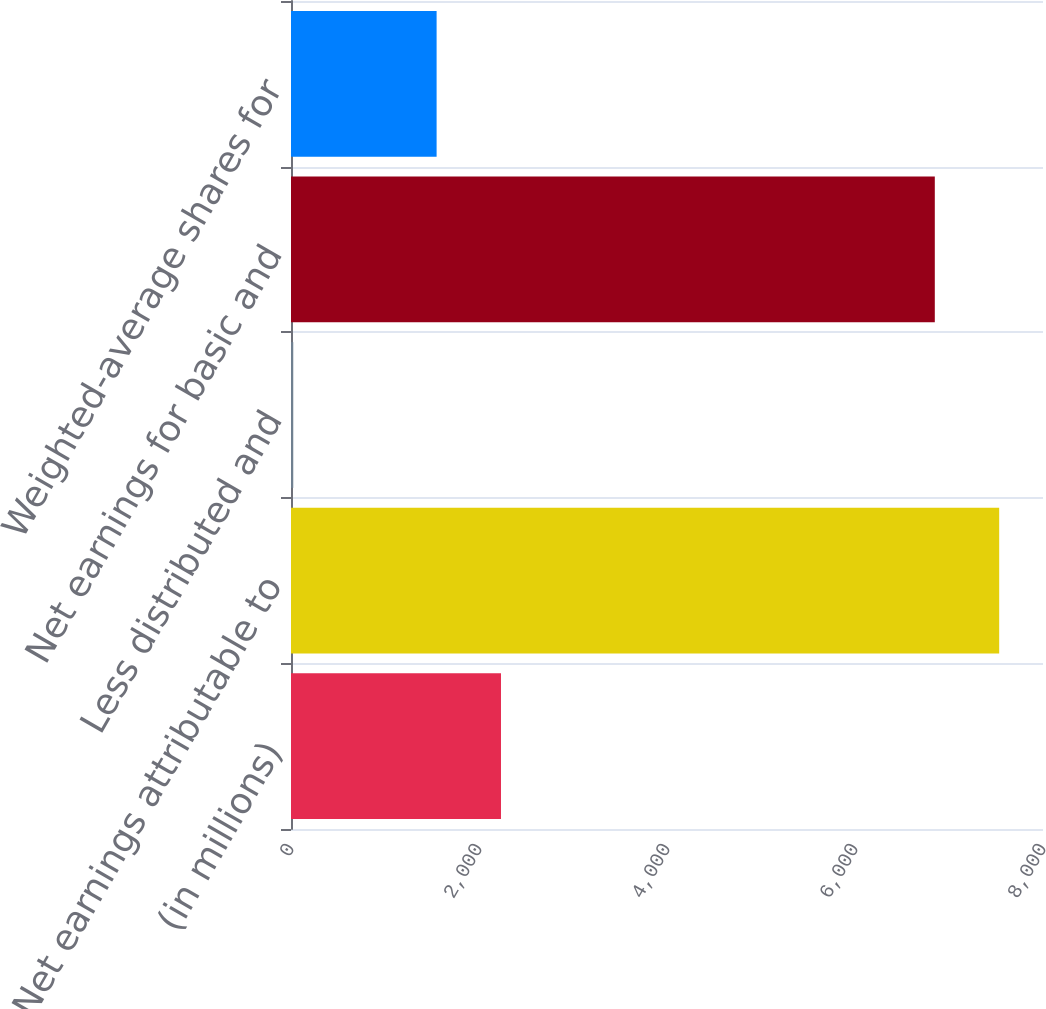<chart> <loc_0><loc_0><loc_500><loc_500><bar_chart><fcel>(in millions)<fcel>Net earnings attributable to<fcel>Less distributed and<fcel>Net earnings for basic and<fcel>Weighted-average shares for<nl><fcel>2233.9<fcel>7533.9<fcel>24<fcel>6849<fcel>1549<nl></chart> 